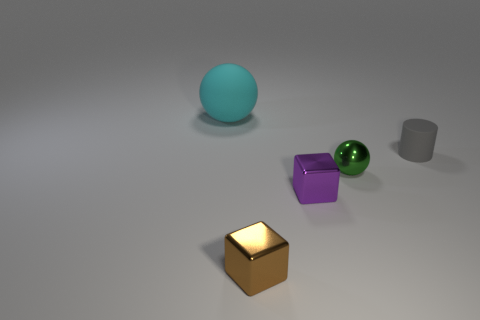There is a rubber object right of the ball that is to the right of the brown metallic object; are there any objects that are behind it?
Offer a terse response. Yes. What number of other rubber things have the same color as the small rubber object?
Keep it short and to the point. 0. What shape is the green object that is the same size as the gray matte thing?
Ensure brevity in your answer.  Sphere. Are there any cyan rubber objects in front of the small brown thing?
Your answer should be very brief. No. Does the green sphere have the same size as the cyan ball?
Offer a terse response. No. There is a metal object that is in front of the purple metallic cube; what shape is it?
Keep it short and to the point. Cube. Are there any shiny spheres of the same size as the brown cube?
Keep it short and to the point. Yes. What material is the green sphere that is the same size as the rubber cylinder?
Offer a very short reply. Metal. There is a object behind the gray cylinder; what is its size?
Offer a terse response. Large. What is the size of the gray matte object?
Ensure brevity in your answer.  Small. 